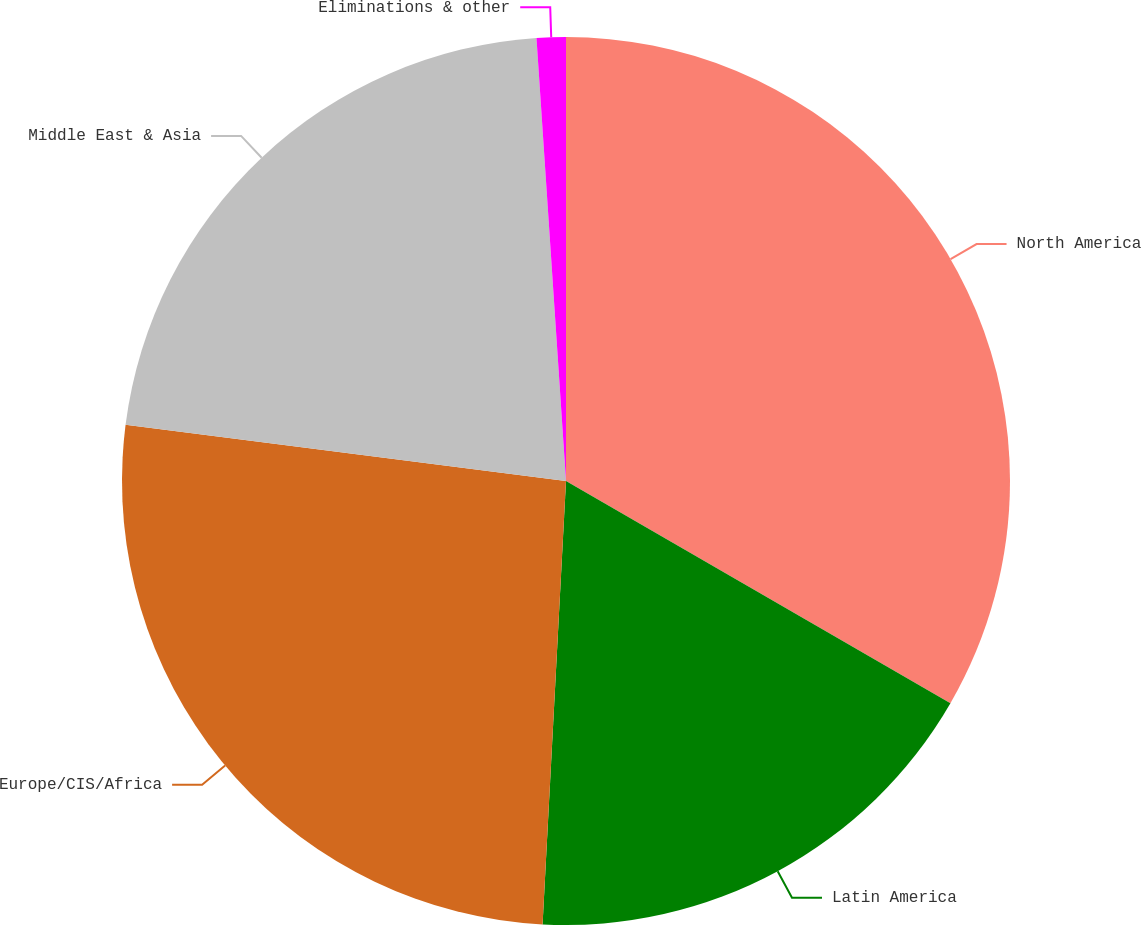Convert chart to OTSL. <chart><loc_0><loc_0><loc_500><loc_500><pie_chart><fcel>North America<fcel>Latin America<fcel>Europe/CIS/Africa<fcel>Middle East & Asia<fcel>Eliminations & other<nl><fcel>33.34%<fcel>17.5%<fcel>26.18%<fcel>21.92%<fcel>1.06%<nl></chart> 